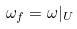Convert formula to latex. <formula><loc_0><loc_0><loc_500><loc_500>\omega _ { f } = \omega | _ { U }</formula> 